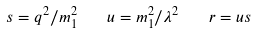<formula> <loc_0><loc_0><loc_500><loc_500>s = q ^ { 2 } / m ^ { 2 } _ { 1 } \quad u = m ^ { 2 } _ { 1 } / \lambda ^ { 2 } \quad r = u s</formula> 